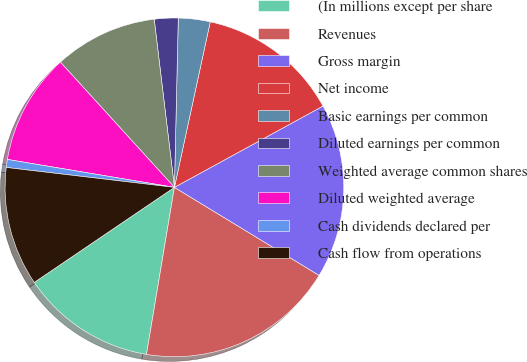<chart> <loc_0><loc_0><loc_500><loc_500><pie_chart><fcel>(In millions except per share<fcel>Revenues<fcel>Gross margin<fcel>Net income<fcel>Basic earnings per common<fcel>Diluted earnings per common<fcel>Weighted average common shares<fcel>Diluted weighted average<fcel>Cash dividends declared per<fcel>Cash flow from operations<nl><fcel>12.88%<fcel>18.94%<fcel>16.67%<fcel>13.64%<fcel>3.03%<fcel>2.27%<fcel>9.85%<fcel>10.61%<fcel>0.76%<fcel>11.36%<nl></chart> 